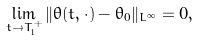Convert formula to latex. <formula><loc_0><loc_0><loc_500><loc_500>\lim _ { t \rightarrow T _ { 1 } ^ { + } } \| \theta ( t , \cdot ) - \theta _ { 0 } \| _ { L ^ { \infty } } = 0 ,</formula> 